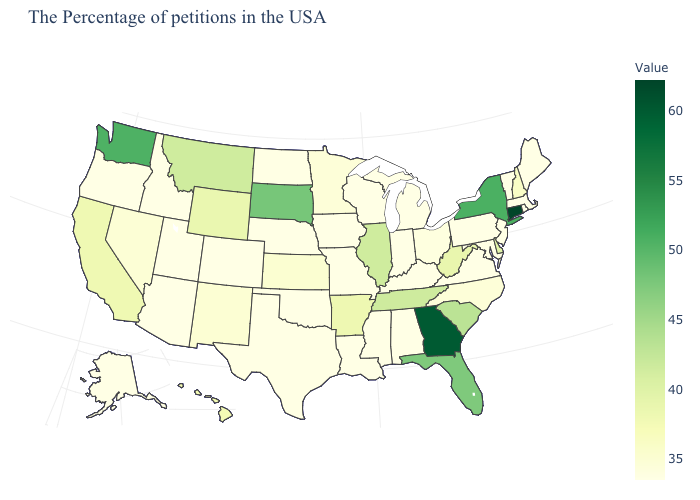Which states have the lowest value in the USA?
Quick response, please. Maine, Massachusetts, Rhode Island, Vermont, New Jersey, Maryland, Pennsylvania, Virginia, Michigan, Kentucky, Indiana, Alabama, Wisconsin, Mississippi, Louisiana, Missouri, Iowa, Nebraska, Oklahoma, Colorado, Utah, Arizona, Idaho, Oregon, Alaska. Which states have the lowest value in the USA?
Answer briefly. Maine, Massachusetts, Rhode Island, Vermont, New Jersey, Maryland, Pennsylvania, Virginia, Michigan, Kentucky, Indiana, Alabama, Wisconsin, Mississippi, Louisiana, Missouri, Iowa, Nebraska, Oklahoma, Colorado, Utah, Arizona, Idaho, Oregon, Alaska. 